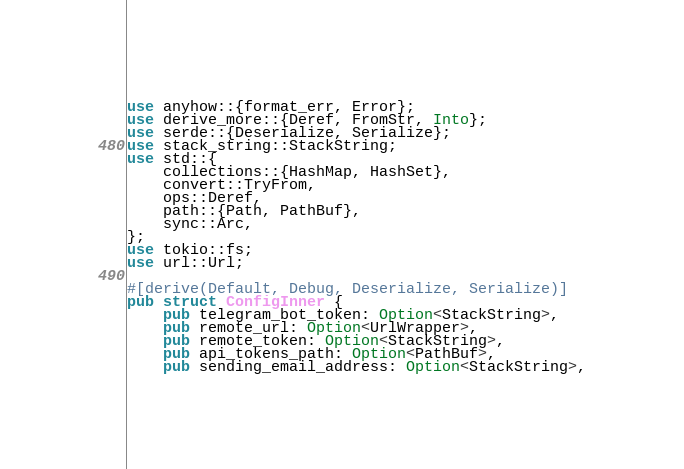Convert code to text. <code><loc_0><loc_0><loc_500><loc_500><_Rust_>use anyhow::{format_err, Error};
use derive_more::{Deref, FromStr, Into};
use serde::{Deserialize, Serialize};
use stack_string::StackString;
use std::{
    collections::{HashMap, HashSet},
    convert::TryFrom,
    ops::Deref,
    path::{Path, PathBuf},
    sync::Arc,
};
use tokio::fs;
use url::Url;

#[derive(Default, Debug, Deserialize, Serialize)]
pub struct ConfigInner {
    pub telegram_bot_token: Option<StackString>,
    pub remote_url: Option<UrlWrapper>,
    pub remote_token: Option<StackString>,
    pub api_tokens_path: Option<PathBuf>,
    pub sending_email_address: Option<StackString>,</code> 